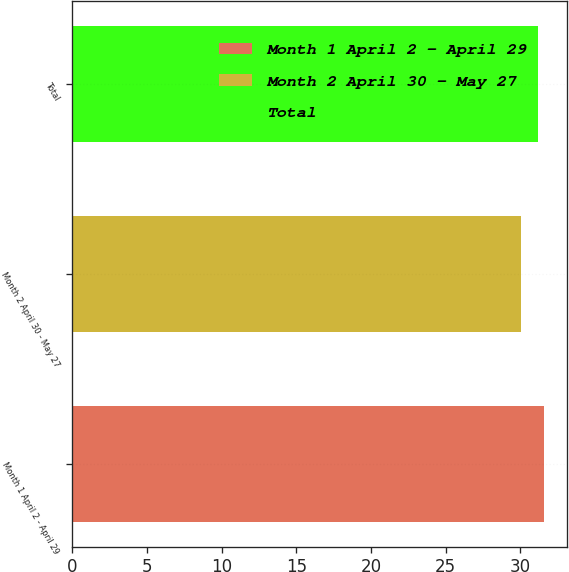<chart> <loc_0><loc_0><loc_500><loc_500><bar_chart><fcel>Month 1 April 2 - April 29<fcel>Month 2 April 30 - May 27<fcel>Total<nl><fcel>31.59<fcel>30.04<fcel>31.2<nl></chart> 